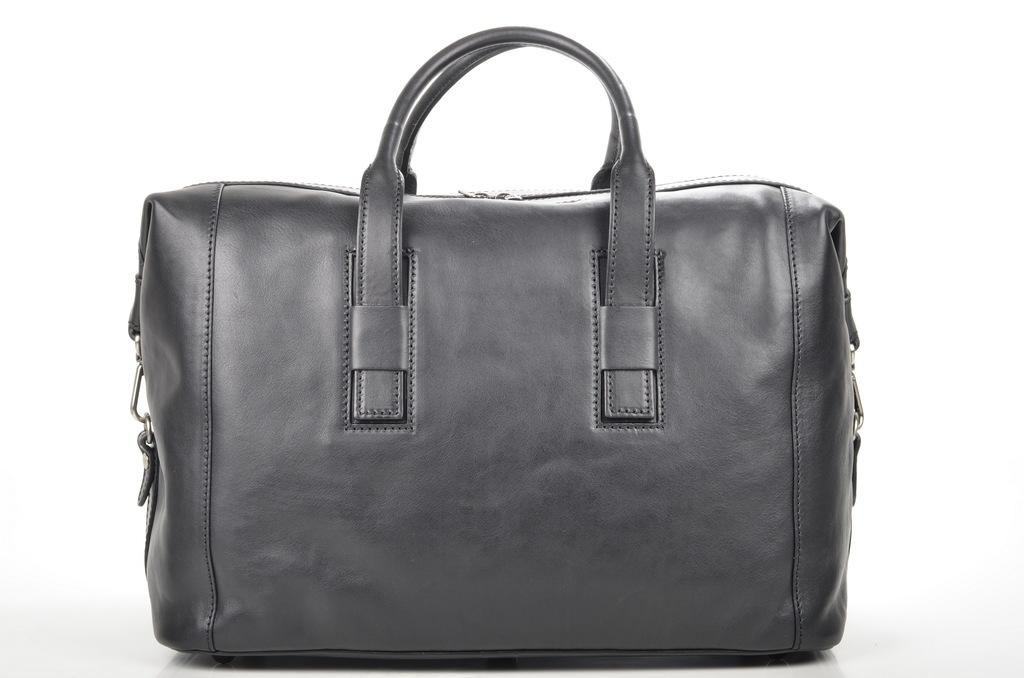What object can be seen in the image? There is a bag in the image. What type of plants can be seen growing inside the bag in the image? There are no plants visible in the image, as it only features a bag. 